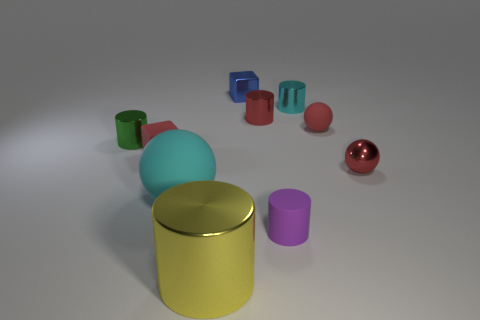Are there the same number of cylinders that are in front of the small cyan thing and tiny purple cylinders that are behind the tiny rubber cube? Upon reviewing the image, it appears that the number of cylinders in front of the small cyan object does not match the number of tiny purple cylinders behind the tiny rubber cube. A detailed count and comparison reveal the discrepancy between them. 